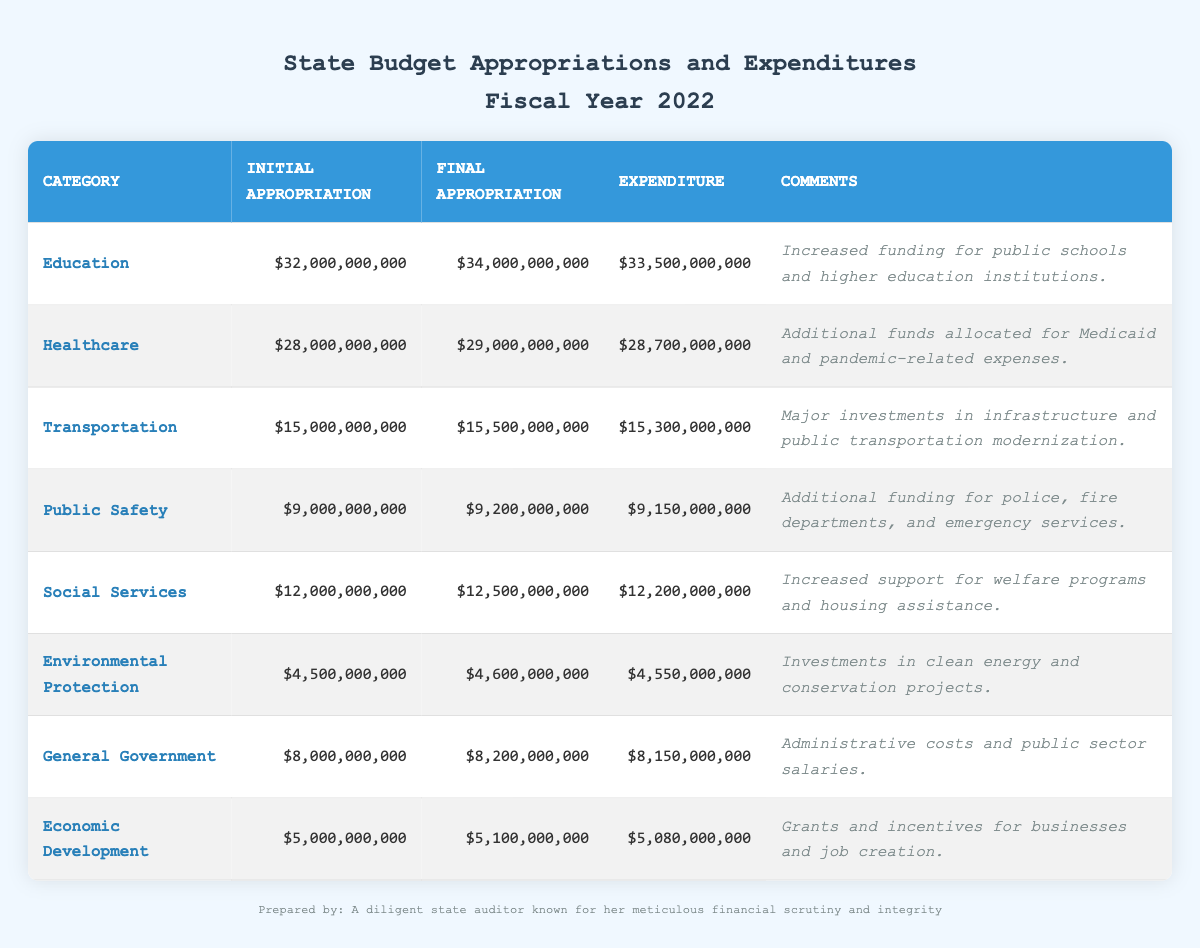What was the initial appropriation for education? The initial appropriation for education is listed in the education section of the table as 32,000,000,000.
Answer: 32,000,000,000 Which category had the highest final appropriation? The final appropriation values for each category are as follows: Education (34,000,000,000), Healthcare (29,000,000,000), Transportation (15,500,000,000), Public Safety (9,200,000,000), Social Services (12,500,000,000), Environmental Protection (4,600,000,000), General Government (8,200,000,000), and Economic Development (5,100,000,000). Therefore, Education had the highest final appropriation at 34,000,000,000.
Answer: Education What is the difference between the final appropriation and expenditure for healthcare? For healthcare, the final appropriation is 29,000,000,000 and the expenditure is 28,700,000,000. The difference can be calculated as follows: 29,000,000,000 - 28,700,000,000 = 300,000,000.
Answer: 300,000,000 Was the expenditure for transportation less than its final appropriation? The final appropriation for transportation is 15,500,000,000 and the expenditure is 15,300,000,000. Since 15,300,000,000 is less than 15,500,000,000, this statement is true.
Answer: Yes What is the total expenditure across all categories? To calculate the total expenditure, we sum up the expenditures from each category: 33,500,000,000 (Education) + 28,700,000,000 (Healthcare) + 15,300,000,000 (Transportation) + 9,150,000,000 (Public Safety) + 12,200,000,000 (Social Services) + 4,550,000,000 (Environmental Protection) + 8,150,000,000 (General Government) + 5,080,000,000 (Economic Development). This totals 117,630,000,000.
Answer: 117,630,000,000 What percentages of the final appropriations were spent in each category? The percentages can be calculated by dividing each expenditure by its final appropriation and multiplying by 100: Education: (33,500,000,000 / 34,000,000,000) * 100 = 98.53%, Healthcare: (28,700,000,000 / 29,000,000,000) * 100 = 98.96%, Transportation: (15,300,000,000 / 15,500,000,000) * 100 = 98.71%, Public Safety: (9,150,000,000 / 9,200,000,000) * 100 = 99.46%, Social Services: (12,200,000,000 / 12,500,000,000) * 100 = 97.60%, Environmental Protection: (4,550,000,000 / 4,600,000,000) * 100 = 98.91%, General Government: (8,150,000,000 / 8,200,000,000) * 100 = 99.39%, Economic Development: (5,080,000,000 / 5,100,000,000) * 100 = 99.61%.
Answer: Varies by category 